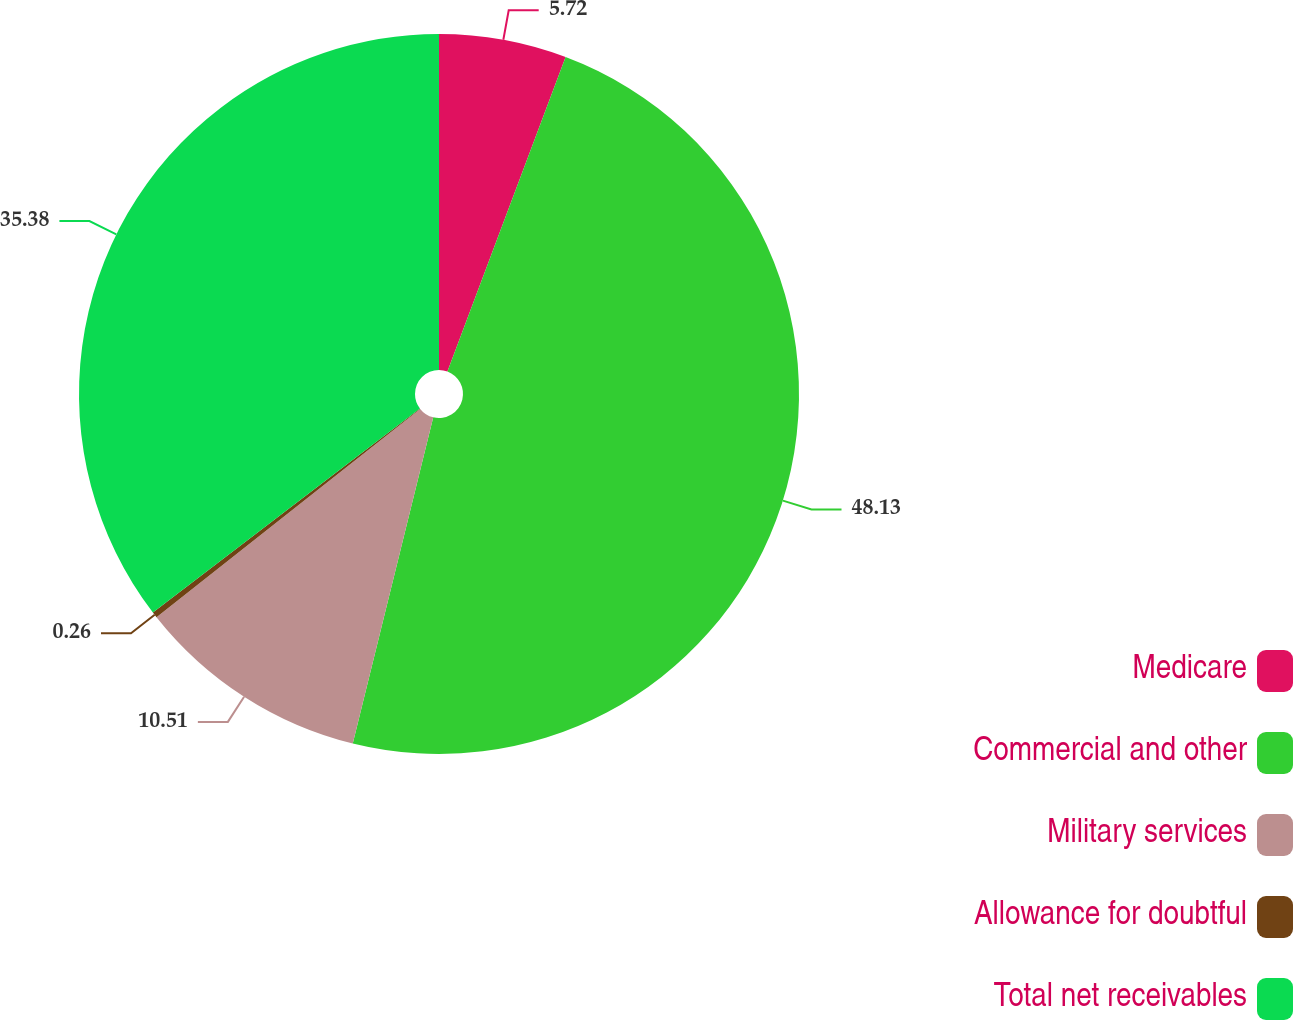Convert chart. <chart><loc_0><loc_0><loc_500><loc_500><pie_chart><fcel>Medicare<fcel>Commercial and other<fcel>Military services<fcel>Allowance for doubtful<fcel>Total net receivables<nl><fcel>5.72%<fcel>48.13%<fcel>10.51%<fcel>0.26%<fcel>35.38%<nl></chart> 